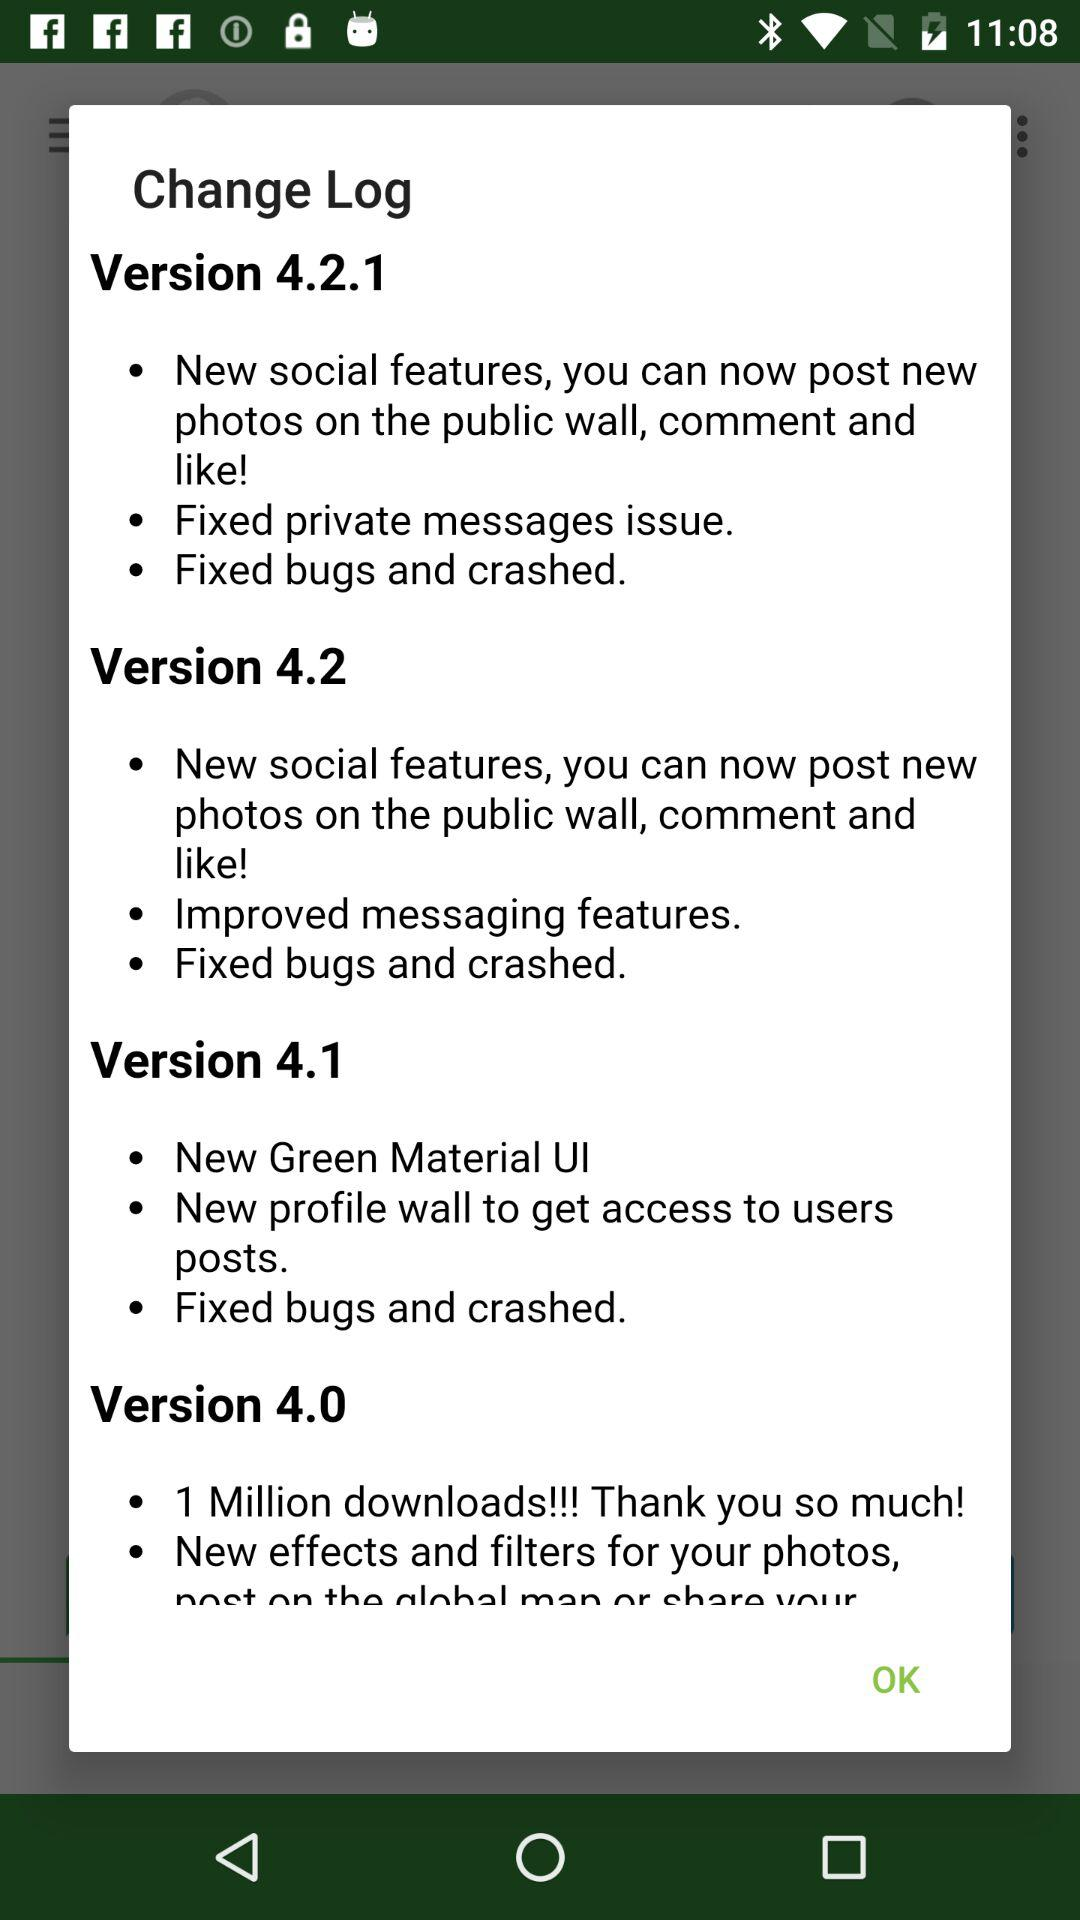What is the change log in version 4.1? The change logs in version 4.1 are "New Green Material UI", "New profile wall to get access to users posts." and "Fixed bugs and crashed". 